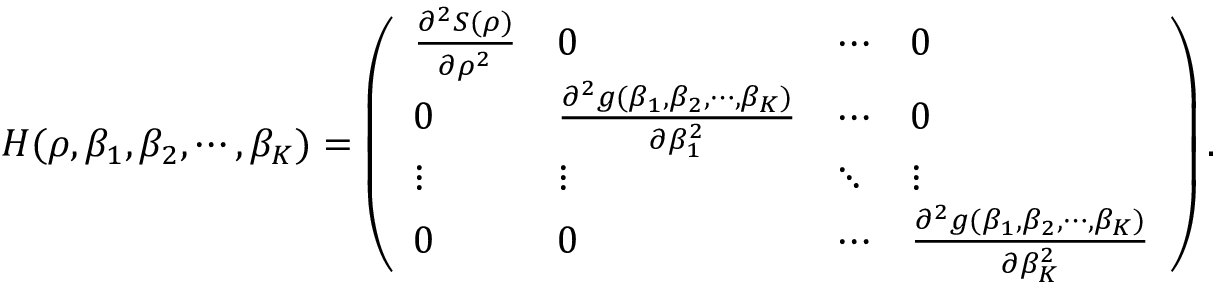Convert formula to latex. <formula><loc_0><loc_0><loc_500><loc_500>\begin{array} { r l } & { H ( \rho , \beta _ { 1 } , \beta _ { 2 } , \cdots , \beta _ { K } ) = \left ( \begin{array} { l l l l } { \frac { \partial ^ { 2 } S ( \rho ) } { \partial \rho ^ { 2 } } } & { 0 } & { \cdots } & { 0 } \\ { 0 } & { \frac { \partial ^ { 2 } g ( \beta _ { 1 } , \beta _ { 2 } , \cdots , \beta _ { K } ) } { \partial \beta _ { 1 } ^ { 2 } } } & { \cdots } & { 0 } \\ { \vdots } & { \vdots } & { \ddots } & { \vdots } \\ { 0 } & { 0 } & { \cdots } & { \frac { \partial ^ { 2 } g ( \beta _ { 1 } , \beta _ { 2 } , \cdots , \beta _ { K } ) } { \partial \beta _ { K } ^ { 2 } } } \end{array} \right ) . } \end{array}</formula> 